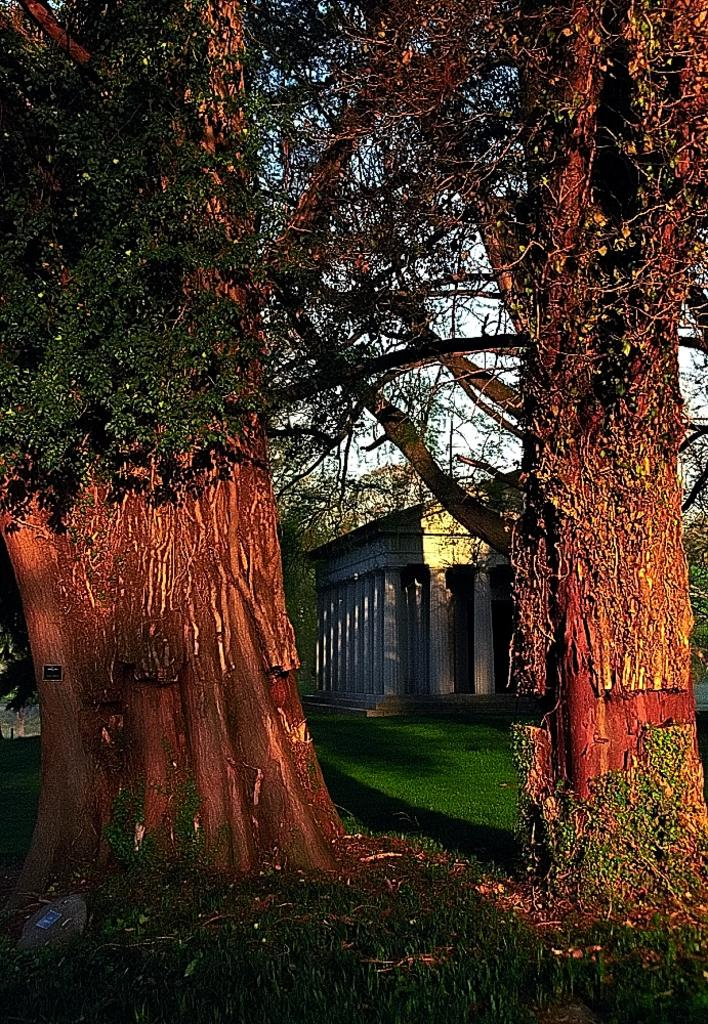What type of vegetation can be seen in the image? There are trees in the image. What type of structure is visible in the image? There is a house in the image. What is visible at the bottom of the image? The ground is visible at the bottom of the image. What is the size of the camp in the image? There is no camp present in the image; it features trees and a house. What type of fear is depicted in the image? There is no fear depicted in the image; it shows trees, a house, and the ground. 